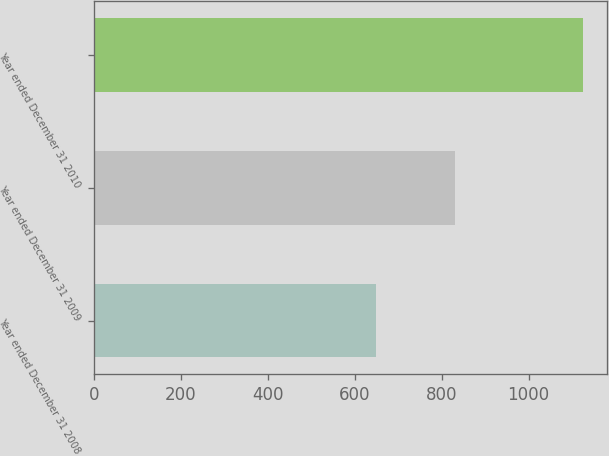Convert chart. <chart><loc_0><loc_0><loc_500><loc_500><bar_chart><fcel>Year ended December 31 2008<fcel>Year ended December 31 2009<fcel>Year ended December 31 2010<nl><fcel>648<fcel>831<fcel>1125<nl></chart> 